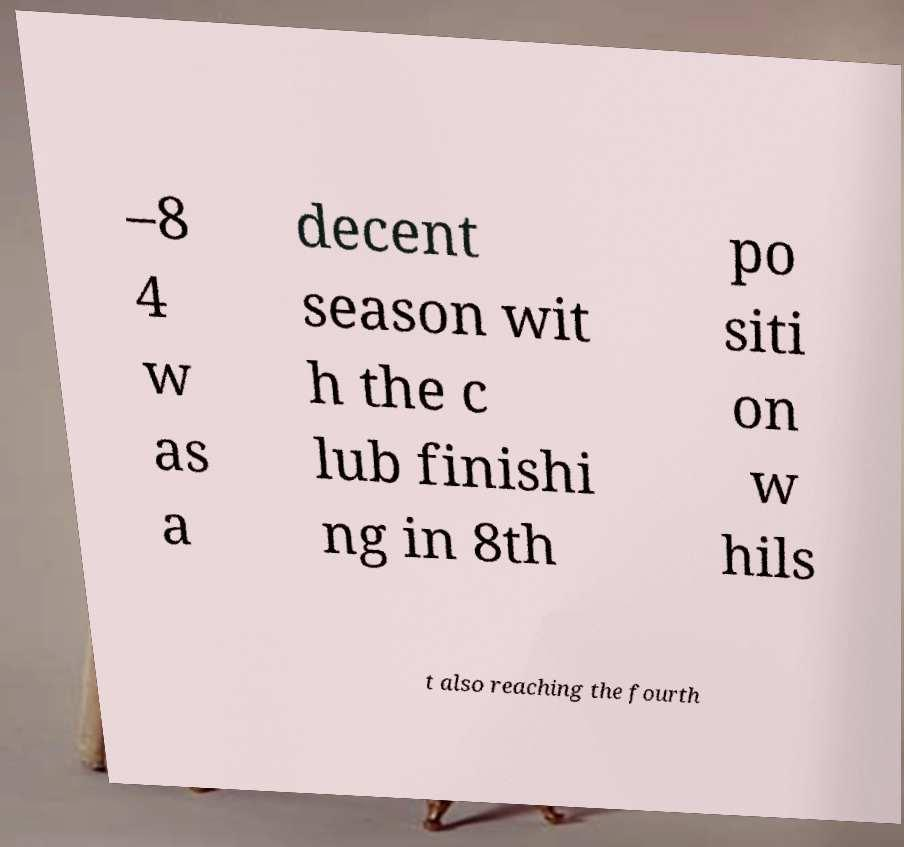Can you read and provide the text displayed in the image?This photo seems to have some interesting text. Can you extract and type it out for me? –8 4 w as a decent season wit h the c lub finishi ng in 8th po siti on w hils t also reaching the fourth 